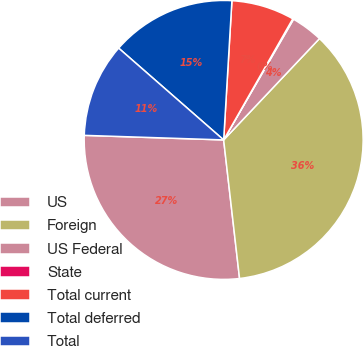Convert chart. <chart><loc_0><loc_0><loc_500><loc_500><pie_chart><fcel>US<fcel>Foreign<fcel>US Federal<fcel>State<fcel>Total current<fcel>Total deferred<fcel>Total<nl><fcel>27.34%<fcel>36.13%<fcel>3.7%<fcel>0.1%<fcel>7.31%<fcel>14.51%<fcel>10.91%<nl></chart> 